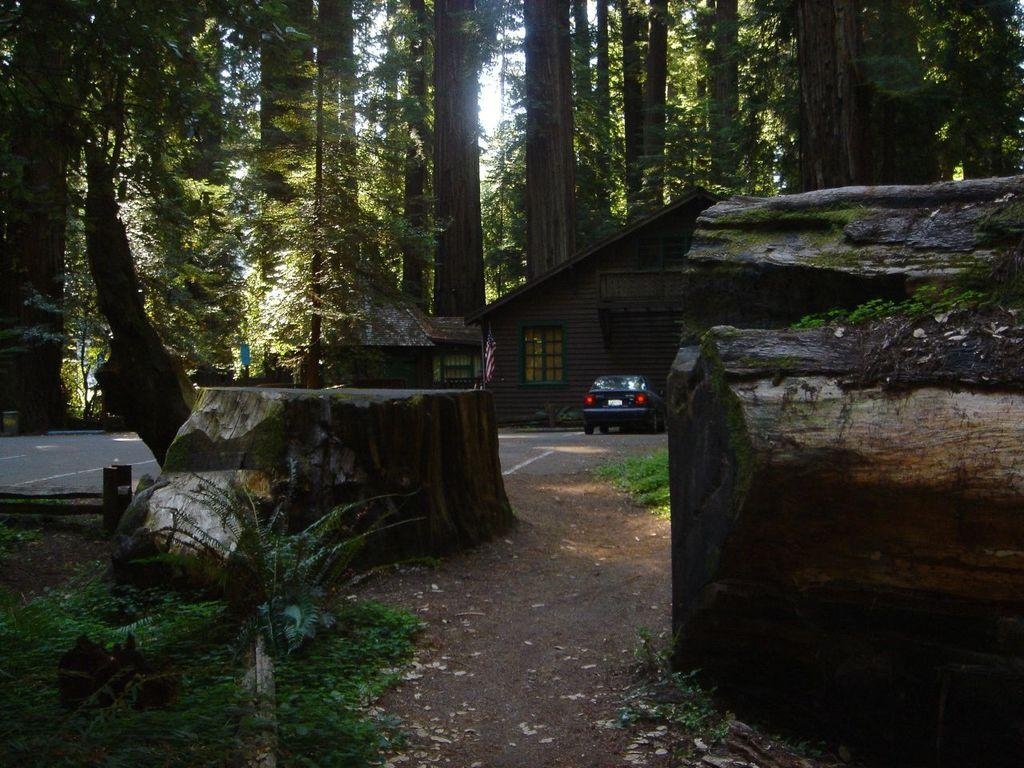What is the condition of the tree trunks in the image? The tree trunks are cut in the image. What type of vegetation is present in the image? There are plants in the image. What can be seen near the plants? A vehicle is parked in the image. What type of structure is visible in the image? There is a wooden house in the image. What is visible in the background of the image? Trees are visible in the background of the image. How many yokes are being used to cover the plants in the image? There are no yokes present in the image, and plants are not being covered. 